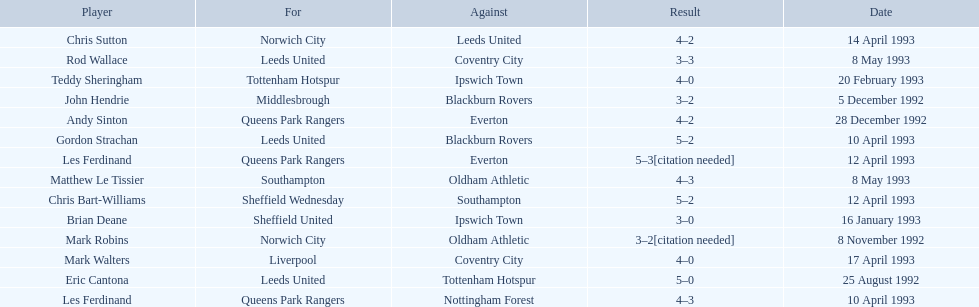Southampton played on may 8th, 1993, who was their opponent? Oldham Athletic. 